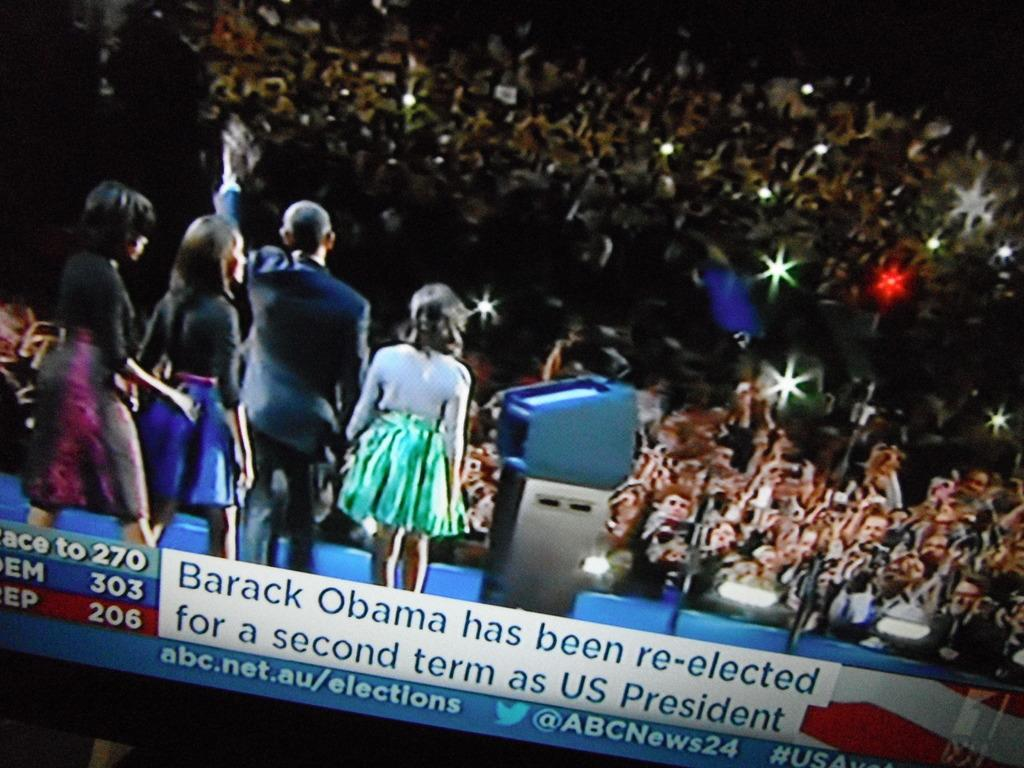How many people are in the image? There is a group of persons in the image. What are the persons in the image doing? The persons are standing. Can you describe any objects or features in the image? There is a light in the image. What type of connection can be seen between the persons in the image? There is no specific connection visible between the persons in the image; they are simply standing. 